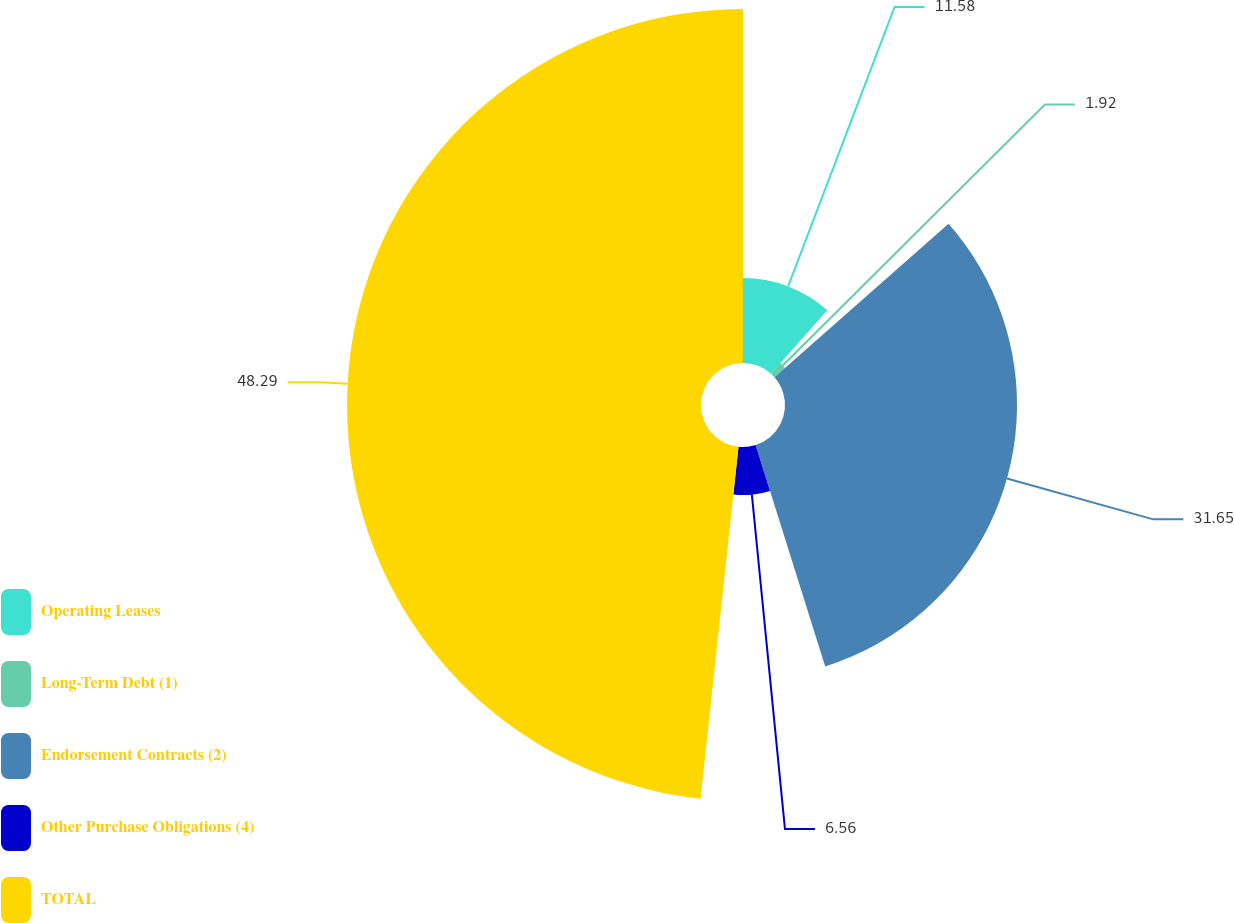<chart> <loc_0><loc_0><loc_500><loc_500><pie_chart><fcel>Operating Leases<fcel>Long-Term Debt (1)<fcel>Endorsement Contracts (2)<fcel>Other Purchase Obligations (4)<fcel>TOTAL<nl><fcel>11.58%<fcel>1.92%<fcel>31.65%<fcel>6.56%<fcel>48.29%<nl></chart> 